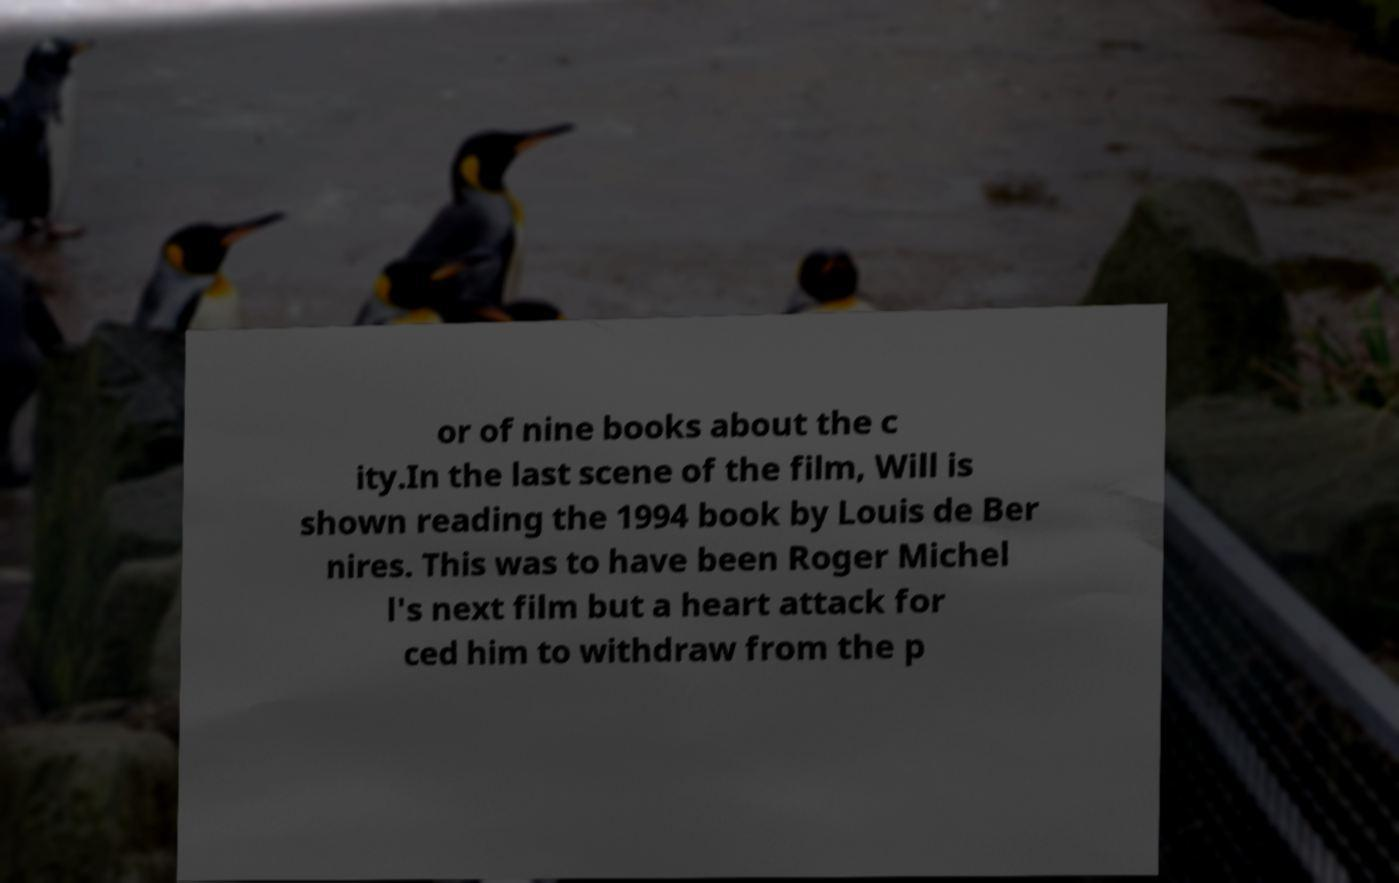Please identify and transcribe the text found in this image. or of nine books about the c ity.In the last scene of the film, Will is shown reading the 1994 book by Louis de Ber nires. This was to have been Roger Michel l's next film but a heart attack for ced him to withdraw from the p 